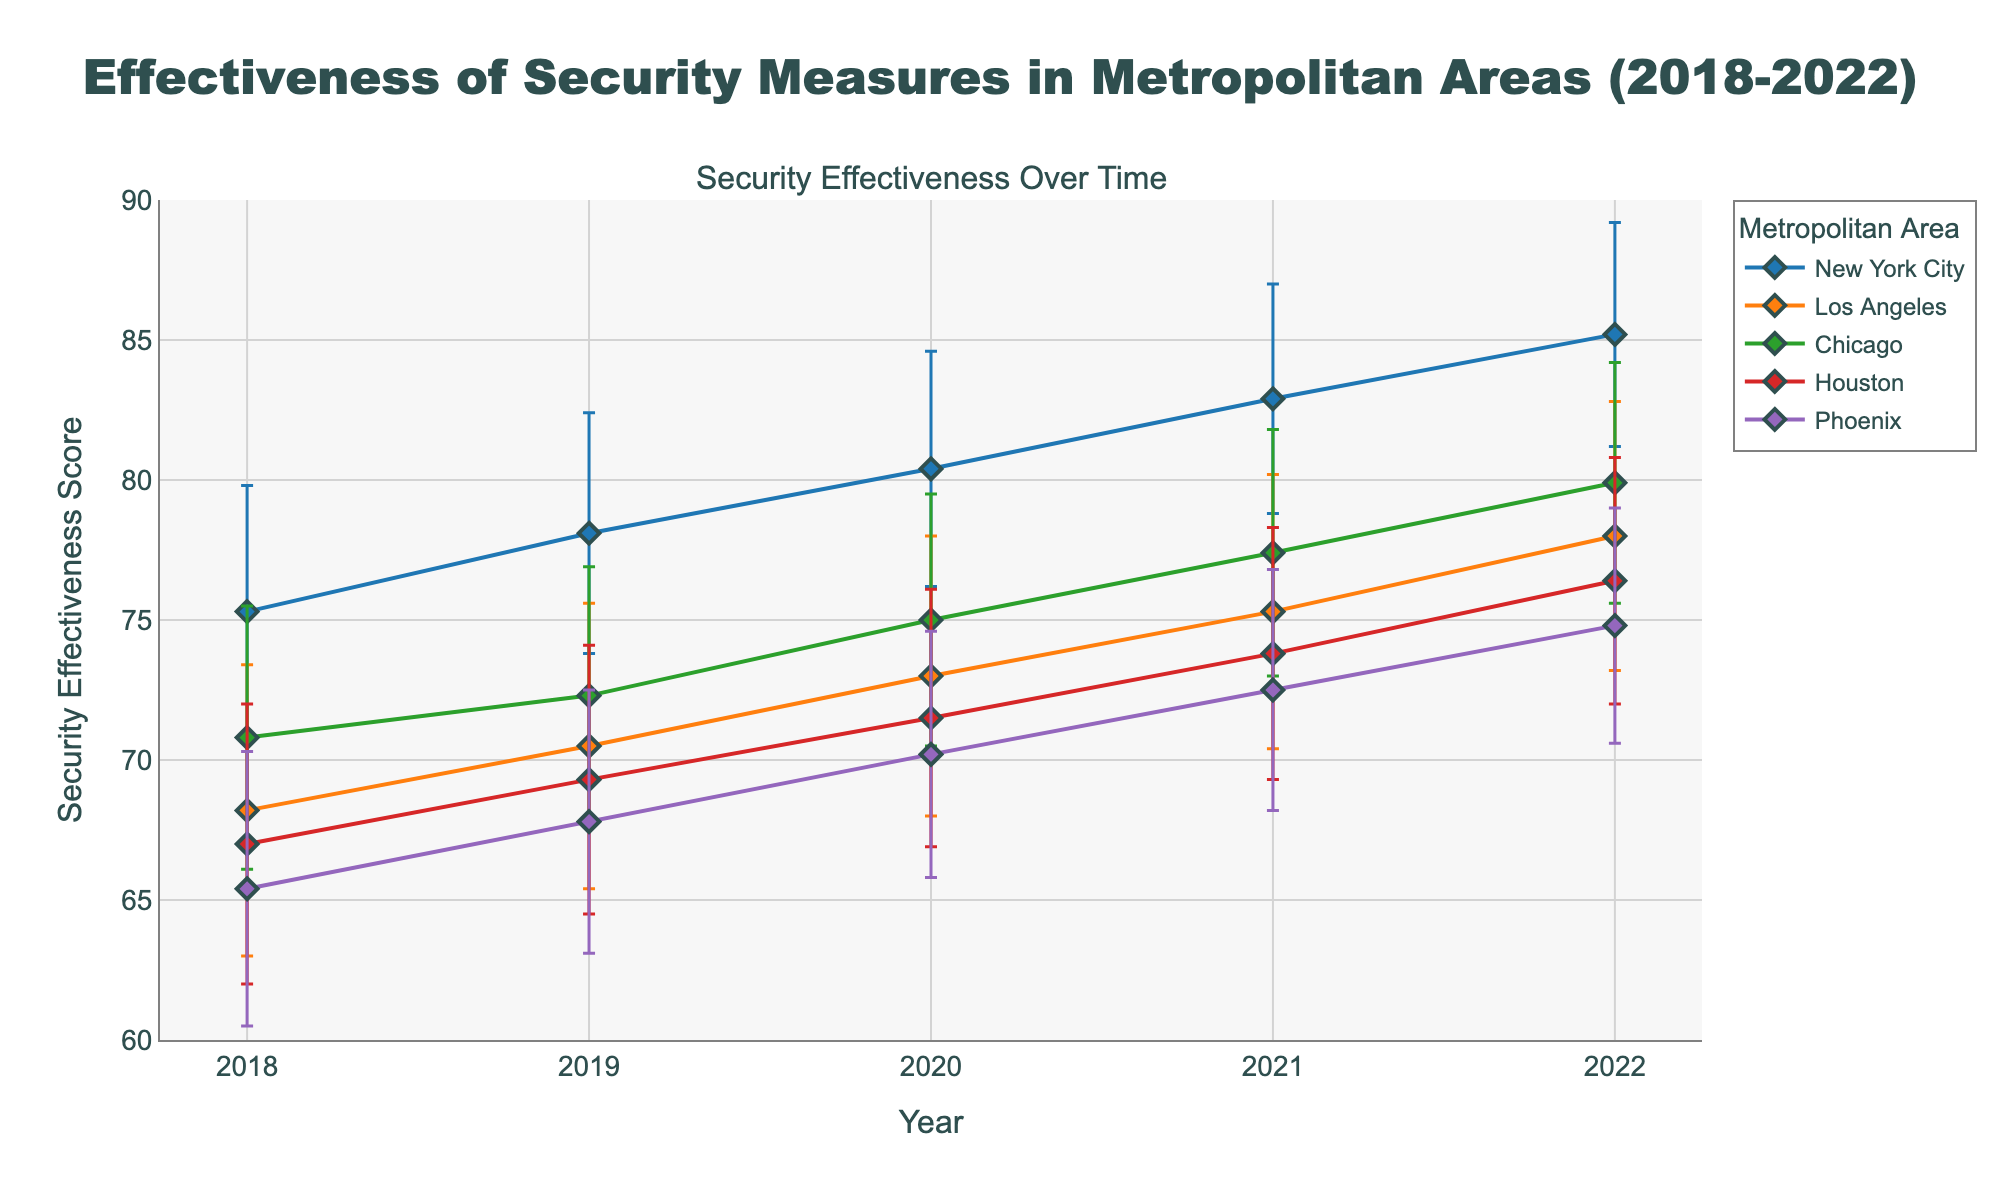What is the title of the plot? The title is located at the top of the figure and summarizes the main topic being visualized. The title here is 'Effectiveness of Security Measures in Metropolitan Areas (2018-2022)'.
Answer: Effectiveness of Security Measures in Metropolitan Areas (2018-2022) What does the y-axis represent? The label of the y-axis explains what is being measured vertically. It represents 'Security Effectiveness Score'.
Answer: Security Effectiveness Score Which metropolitan area had the highest security effectiveness score in 2022? By looking at the data points for the year 2022, New York City has the highest value, which is at 85.2.
Answer: New York City Between which years did Los Angeles see the greatest increase in security effectiveness? We compare the scores for Los Angeles between consecutive years. The greatest increase is between 2019 (70.5) and 2020 (73.0), resulting in an increment of 2.5.
Answer: 2019 and 2020 How does the trend in security effectiveness for New York City compare with that of Phoenix between 2018 and 2022? By examining the plot, New York City's security effectiveness consistently increases each year, whereas Phoenix also increases but follows a slightly lower and less steep trajectory.
Answer: New York City shows a steeper and consistently increasing trend compared to Phoenix What is the average security effectiveness score for Chicago from 2018 to 2022? Security effectiveness scores for Chicago: (70.8, 72.3, 75.0, 77.4, 79.9). The average is calculated by summing these values and dividing by the count. (70.8 + 72.3 + 75.0 + 77.4 + 79.9) / 5 = 75.08
Answer: 75.08 Which metropolitan area had the most variation in security effectiveness scores? The variation can be interpreted by looking at the height of the error bars. Los Angeles has the highest standard deviations in most years, indicating the most variation.
Answer: Los Angeles Did Houston ever have a higher security effectiveness score than Phoenix during 2018-2022? By comparing their respective data points across each year, Houston's scores are consistently higher than Phoenix's in all given years.
Answer: Yes, in all years What is the difference in security effectiveness scores between New York City and Chicago in 2021? For 2021, New York City scored 82.9 while Chicago scored 77.4. The difference is calculated as 82.9 - 77.4 = 5.5.
Answer: 5.5 Which year had the smallest overall range of security effectiveness scores among all metropolitan areas? To find the range for each year, we identify the highest and lowest scores: 2018 (75.3 - 65.4 = 9.9), 2019 (78.1 - 67.8 = 10.3), 2020 (80.4 - 70.2 = 10.2), 2021 (82.9 - 72.5 = 10.4), 2022 (85.2 - 74.8 = 10.4). The year 2018 had the smallest range of 9.9.
Answer: 2018 